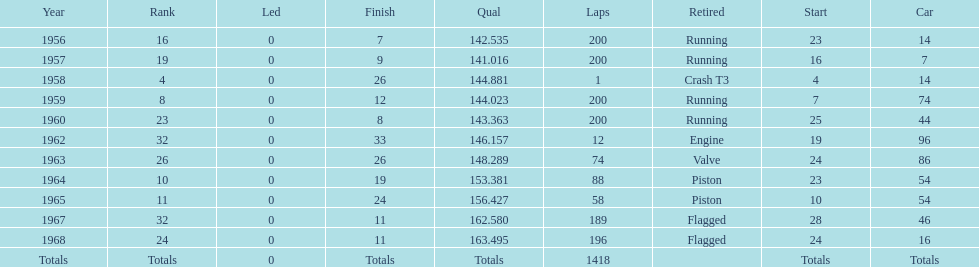What is the larger laps between 1963 or 1968 1968. 